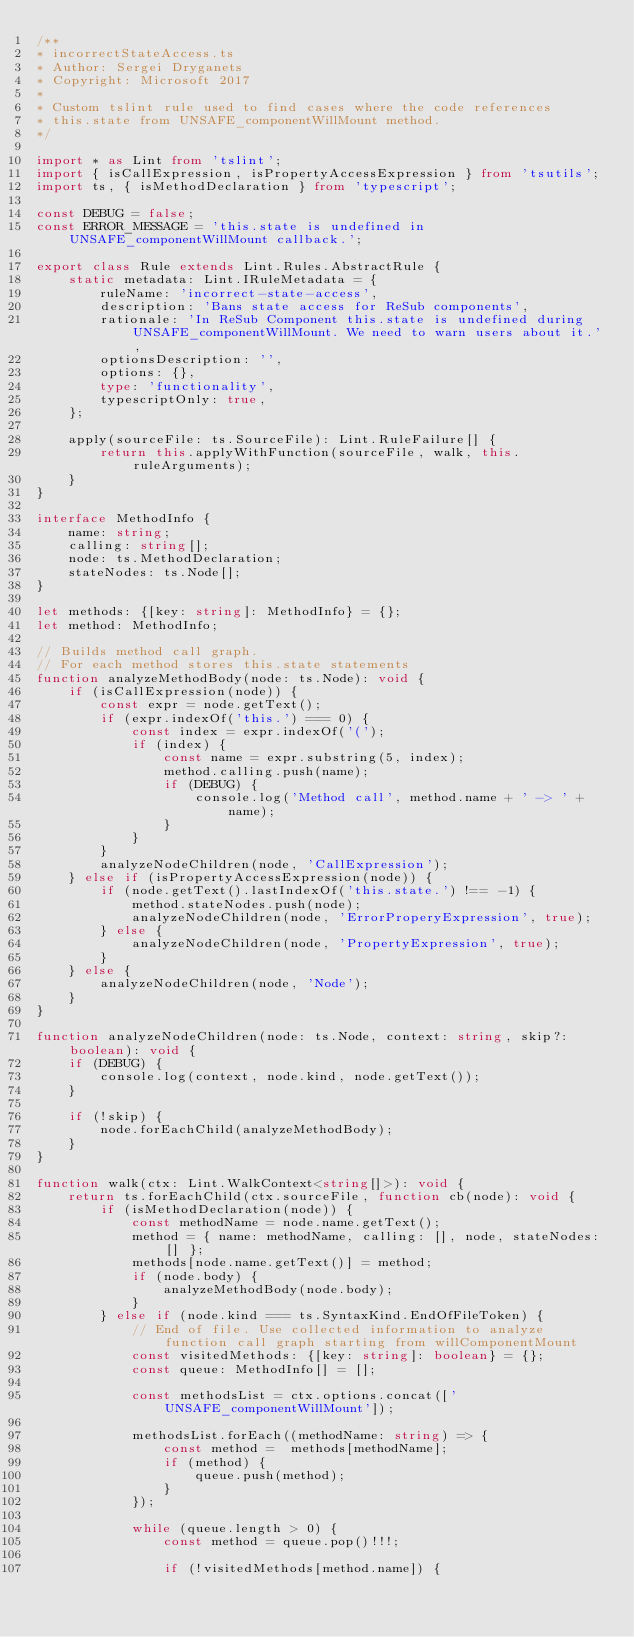Convert code to text. <code><loc_0><loc_0><loc_500><loc_500><_TypeScript_>/**
* incorrectStateAccess.ts
* Author: Sergei Dryganets
* Copyright: Microsoft 2017
*
* Custom tslint rule used to find cases where the code references
* this.state from UNSAFE_componentWillMount method.
*/

import * as Lint from 'tslint';
import { isCallExpression, isPropertyAccessExpression } from 'tsutils';
import ts, { isMethodDeclaration } from 'typescript';

const DEBUG = false;
const ERROR_MESSAGE = 'this.state is undefined in UNSAFE_componentWillMount callback.';

export class Rule extends Lint.Rules.AbstractRule {
    static metadata: Lint.IRuleMetadata = {
        ruleName: 'incorrect-state-access',
        description: 'Bans state access for ReSub components',
        rationale: 'In ReSub Component this.state is undefined during UNSAFE_componentWillMount. We need to warn users about it.',
        optionsDescription: '',
        options: {},
        type: 'functionality',
        typescriptOnly: true,
    };

    apply(sourceFile: ts.SourceFile): Lint.RuleFailure[] {
        return this.applyWithFunction(sourceFile, walk, this.ruleArguments);
    }
}

interface MethodInfo {
    name: string;
    calling: string[];
    node: ts.MethodDeclaration;
    stateNodes: ts.Node[];
}

let methods: {[key: string]: MethodInfo} = {};
let method: MethodInfo;

// Builds method call graph.
// For each method stores this.state statements
function analyzeMethodBody(node: ts.Node): void {
    if (isCallExpression(node)) {
        const expr = node.getText();
        if (expr.indexOf('this.') === 0) {
            const index = expr.indexOf('(');
            if (index) {
                const name = expr.substring(5, index);
                method.calling.push(name);
                if (DEBUG) {
                    console.log('Method call', method.name + ' -> ' + name);
                }
            }
        }
        analyzeNodeChildren(node, 'CallExpression');
    } else if (isPropertyAccessExpression(node)) {
        if (node.getText().lastIndexOf('this.state.') !== -1) {
            method.stateNodes.push(node);
            analyzeNodeChildren(node, 'ErrorProperyExpression', true);
        } else {
            analyzeNodeChildren(node, 'PropertyExpression', true);
        }
    } else {
        analyzeNodeChildren(node, 'Node');
    }
}

function analyzeNodeChildren(node: ts.Node, context: string, skip?: boolean): void {
    if (DEBUG) {
        console.log(context, node.kind, node.getText());
    }

    if (!skip) {
        node.forEachChild(analyzeMethodBody);
    }
}

function walk(ctx: Lint.WalkContext<string[]>): void {
    return ts.forEachChild(ctx.sourceFile, function cb(node): void {
        if (isMethodDeclaration(node)) {
            const methodName = node.name.getText();
            method = { name: methodName, calling: [], node, stateNodes: [] };
            methods[node.name.getText()] = method;
            if (node.body) {
                analyzeMethodBody(node.body);
            }
        } else if (node.kind === ts.SyntaxKind.EndOfFileToken) {
            // End of file. Use collected information to analyze function call graph starting from willComponentMount
            const visitedMethods: {[key: string]: boolean} = {};
            const queue: MethodInfo[] = [];

            const methodsList = ctx.options.concat(['UNSAFE_componentWillMount']);

            methodsList.forEach((methodName: string) => {
                const method =  methods[methodName];
                if (method) {
                    queue.push(method);
                }
            });

            while (queue.length > 0) {
                const method = queue.pop()!!!;

                if (!visitedMethods[method.name]) {</code> 